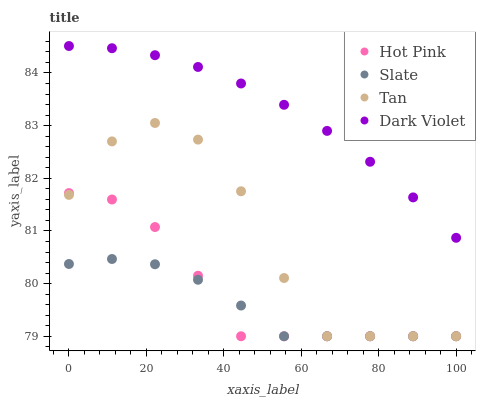Does Slate have the minimum area under the curve?
Answer yes or no. Yes. Does Dark Violet have the maximum area under the curve?
Answer yes or no. Yes. Does Hot Pink have the minimum area under the curve?
Answer yes or no. No. Does Hot Pink have the maximum area under the curve?
Answer yes or no. No. Is Dark Violet the smoothest?
Answer yes or no. Yes. Is Tan the roughest?
Answer yes or no. Yes. Is Hot Pink the smoothest?
Answer yes or no. No. Is Hot Pink the roughest?
Answer yes or no. No. Does Slate have the lowest value?
Answer yes or no. Yes. Does Dark Violet have the lowest value?
Answer yes or no. No. Does Dark Violet have the highest value?
Answer yes or no. Yes. Does Hot Pink have the highest value?
Answer yes or no. No. Is Hot Pink less than Dark Violet?
Answer yes or no. Yes. Is Dark Violet greater than Hot Pink?
Answer yes or no. Yes. Does Tan intersect Hot Pink?
Answer yes or no. Yes. Is Tan less than Hot Pink?
Answer yes or no. No. Is Tan greater than Hot Pink?
Answer yes or no. No. Does Hot Pink intersect Dark Violet?
Answer yes or no. No. 